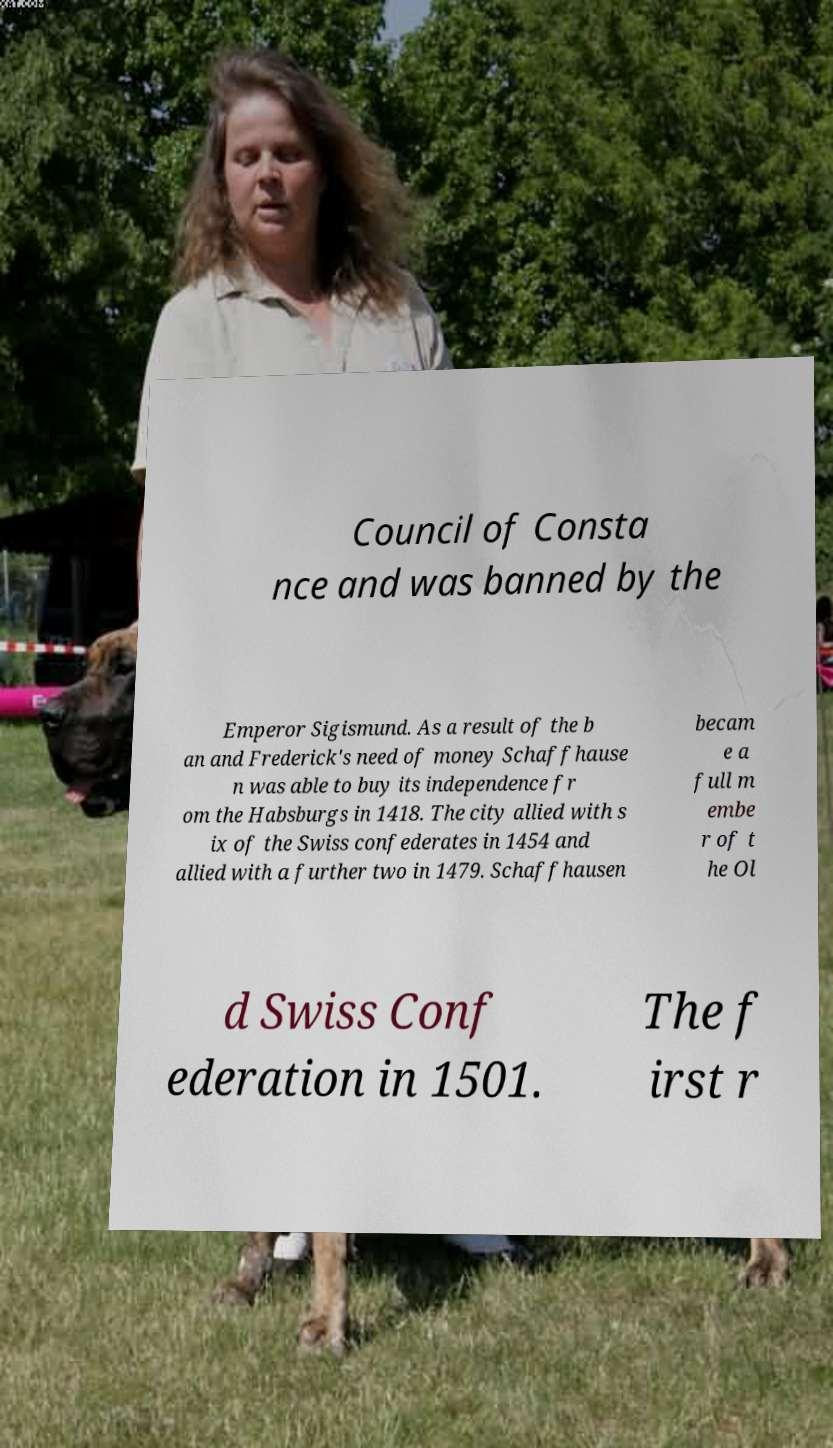I need the written content from this picture converted into text. Can you do that? Council of Consta nce and was banned by the Emperor Sigismund. As a result of the b an and Frederick's need of money Schaffhause n was able to buy its independence fr om the Habsburgs in 1418. The city allied with s ix of the Swiss confederates in 1454 and allied with a further two in 1479. Schaffhausen becam e a full m embe r of t he Ol d Swiss Conf ederation in 1501. The f irst r 